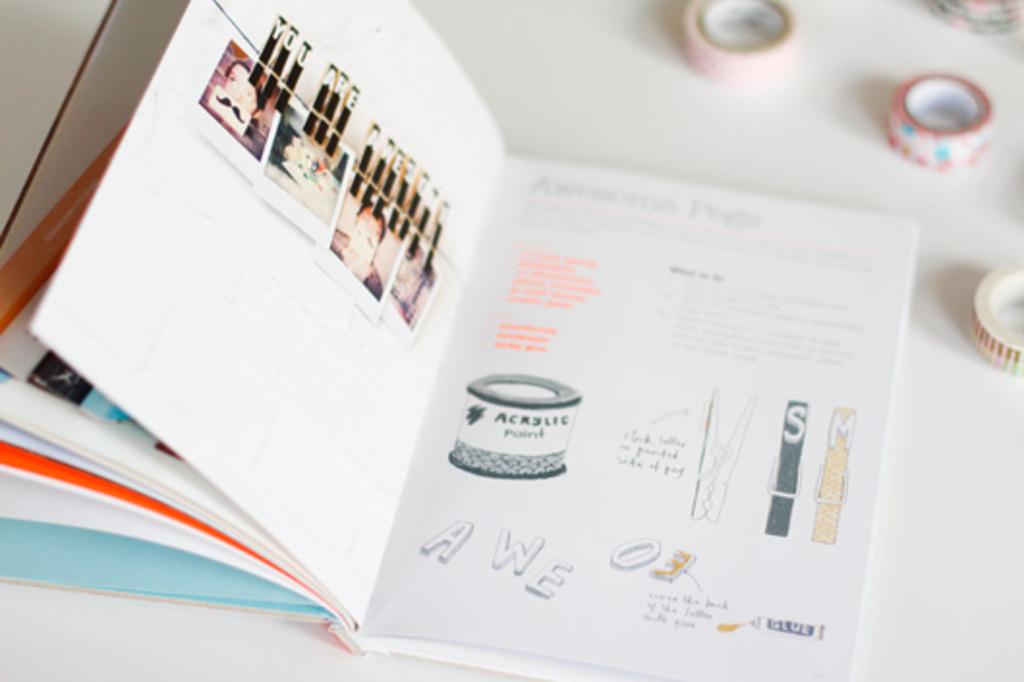What word do the individual, big letters on the second page spell out?
Your answer should be compact. Awe. What letter is on the second clothespin on the right?
Ensure brevity in your answer.  M. 